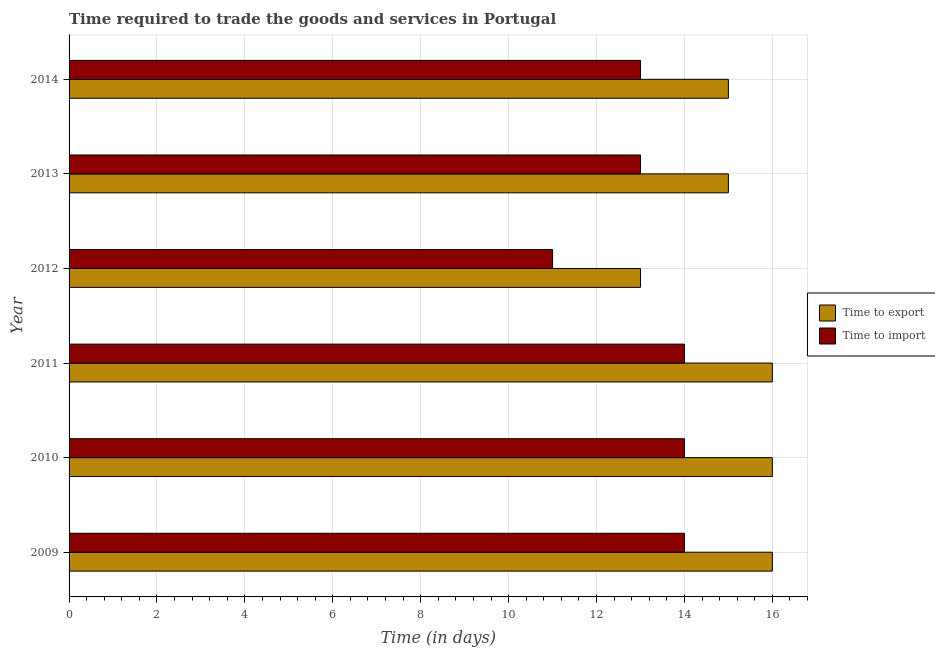How many different coloured bars are there?
Your answer should be compact. 2. Are the number of bars per tick equal to the number of legend labels?
Your answer should be very brief. Yes. Are the number of bars on each tick of the Y-axis equal?
Your response must be concise. Yes. What is the label of the 3rd group of bars from the top?
Your answer should be compact. 2012. What is the time to export in 2014?
Your response must be concise. 15. Across all years, what is the maximum time to export?
Your answer should be very brief. 16. Across all years, what is the minimum time to export?
Your response must be concise. 13. What is the total time to export in the graph?
Your answer should be very brief. 91. What is the difference between the time to export in 2011 and that in 2014?
Ensure brevity in your answer.  1. What is the difference between the time to import in 2010 and the time to export in 2014?
Keep it short and to the point. -1. What is the average time to export per year?
Give a very brief answer. 15.17. In the year 2013, what is the difference between the time to export and time to import?
Ensure brevity in your answer.  2. In how many years, is the time to export greater than 6 days?
Give a very brief answer. 6. What is the ratio of the time to export in 2009 to that in 2011?
Your answer should be very brief. 1. Is the time to export in 2009 less than that in 2010?
Keep it short and to the point. No. What is the difference between the highest and the second highest time to export?
Provide a succinct answer. 0. What is the difference between the highest and the lowest time to export?
Your answer should be very brief. 3. In how many years, is the time to export greater than the average time to export taken over all years?
Your response must be concise. 3. Is the sum of the time to import in 2009 and 2010 greater than the maximum time to export across all years?
Keep it short and to the point. Yes. What does the 2nd bar from the top in 2009 represents?
Offer a terse response. Time to export. What does the 2nd bar from the bottom in 2010 represents?
Your answer should be very brief. Time to import. What is the difference between two consecutive major ticks on the X-axis?
Provide a succinct answer. 2. Does the graph contain any zero values?
Make the answer very short. No. How are the legend labels stacked?
Give a very brief answer. Vertical. What is the title of the graph?
Offer a terse response. Time required to trade the goods and services in Portugal. What is the label or title of the X-axis?
Offer a terse response. Time (in days). What is the Time (in days) of Time to export in 2009?
Keep it short and to the point. 16. What is the Time (in days) in Time to import in 2009?
Keep it short and to the point. 14. What is the Time (in days) in Time to import in 2010?
Ensure brevity in your answer.  14. What is the Time (in days) in Time to export in 2012?
Offer a very short reply. 13. What is the Time (in days) of Time to export in 2013?
Keep it short and to the point. 15. What is the Time (in days) in Time to import in 2013?
Your answer should be very brief. 13. Across all years, what is the maximum Time (in days) of Time to import?
Your response must be concise. 14. Across all years, what is the minimum Time (in days) of Time to import?
Your answer should be very brief. 11. What is the total Time (in days) in Time to export in the graph?
Keep it short and to the point. 91. What is the total Time (in days) in Time to import in the graph?
Your answer should be compact. 79. What is the difference between the Time (in days) in Time to export in 2009 and that in 2010?
Offer a terse response. 0. What is the difference between the Time (in days) in Time to export in 2009 and that in 2013?
Offer a terse response. 1. What is the difference between the Time (in days) of Time to import in 2010 and that in 2012?
Provide a short and direct response. 3. What is the difference between the Time (in days) of Time to import in 2010 and that in 2013?
Offer a very short reply. 1. What is the difference between the Time (in days) in Time to import in 2010 and that in 2014?
Provide a succinct answer. 1. What is the difference between the Time (in days) in Time to export in 2011 and that in 2012?
Your answer should be compact. 3. What is the difference between the Time (in days) in Time to import in 2011 and that in 2013?
Keep it short and to the point. 1. What is the difference between the Time (in days) of Time to export in 2011 and that in 2014?
Offer a terse response. 1. What is the difference between the Time (in days) in Time to export in 2012 and that in 2014?
Make the answer very short. -2. What is the difference between the Time (in days) in Time to import in 2012 and that in 2014?
Provide a short and direct response. -2. What is the difference between the Time (in days) of Time to export in 2013 and that in 2014?
Ensure brevity in your answer.  0. What is the difference between the Time (in days) in Time to import in 2013 and that in 2014?
Provide a short and direct response. 0. What is the difference between the Time (in days) in Time to export in 2009 and the Time (in days) in Time to import in 2012?
Give a very brief answer. 5. What is the difference between the Time (in days) of Time to export in 2010 and the Time (in days) of Time to import in 2013?
Offer a terse response. 3. What is the difference between the Time (in days) of Time to export in 2011 and the Time (in days) of Time to import in 2012?
Your answer should be very brief. 5. What is the difference between the Time (in days) of Time to export in 2011 and the Time (in days) of Time to import in 2013?
Provide a succinct answer. 3. What is the average Time (in days) in Time to export per year?
Your answer should be very brief. 15.17. What is the average Time (in days) of Time to import per year?
Provide a short and direct response. 13.17. In the year 2010, what is the difference between the Time (in days) in Time to export and Time (in days) in Time to import?
Offer a very short reply. 2. In the year 2014, what is the difference between the Time (in days) of Time to export and Time (in days) of Time to import?
Your response must be concise. 2. What is the ratio of the Time (in days) in Time to export in 2009 to that in 2010?
Your response must be concise. 1. What is the ratio of the Time (in days) in Time to export in 2009 to that in 2011?
Your answer should be compact. 1. What is the ratio of the Time (in days) in Time to export in 2009 to that in 2012?
Your answer should be compact. 1.23. What is the ratio of the Time (in days) of Time to import in 2009 to that in 2012?
Your answer should be very brief. 1.27. What is the ratio of the Time (in days) of Time to export in 2009 to that in 2013?
Provide a short and direct response. 1.07. What is the ratio of the Time (in days) of Time to import in 2009 to that in 2013?
Your answer should be very brief. 1.08. What is the ratio of the Time (in days) of Time to export in 2009 to that in 2014?
Provide a succinct answer. 1.07. What is the ratio of the Time (in days) of Time to import in 2009 to that in 2014?
Offer a terse response. 1.08. What is the ratio of the Time (in days) in Time to export in 2010 to that in 2011?
Your answer should be compact. 1. What is the ratio of the Time (in days) of Time to import in 2010 to that in 2011?
Make the answer very short. 1. What is the ratio of the Time (in days) in Time to export in 2010 to that in 2012?
Your answer should be very brief. 1.23. What is the ratio of the Time (in days) of Time to import in 2010 to that in 2012?
Offer a terse response. 1.27. What is the ratio of the Time (in days) of Time to export in 2010 to that in 2013?
Your answer should be compact. 1.07. What is the ratio of the Time (in days) in Time to import in 2010 to that in 2013?
Offer a terse response. 1.08. What is the ratio of the Time (in days) of Time to export in 2010 to that in 2014?
Offer a very short reply. 1.07. What is the ratio of the Time (in days) in Time to export in 2011 to that in 2012?
Your response must be concise. 1.23. What is the ratio of the Time (in days) of Time to import in 2011 to that in 2012?
Your answer should be compact. 1.27. What is the ratio of the Time (in days) in Time to export in 2011 to that in 2013?
Offer a very short reply. 1.07. What is the ratio of the Time (in days) in Time to export in 2011 to that in 2014?
Ensure brevity in your answer.  1.07. What is the ratio of the Time (in days) of Time to import in 2011 to that in 2014?
Your answer should be compact. 1.08. What is the ratio of the Time (in days) of Time to export in 2012 to that in 2013?
Provide a succinct answer. 0.87. What is the ratio of the Time (in days) of Time to import in 2012 to that in 2013?
Offer a very short reply. 0.85. What is the ratio of the Time (in days) in Time to export in 2012 to that in 2014?
Your response must be concise. 0.87. What is the ratio of the Time (in days) in Time to import in 2012 to that in 2014?
Provide a short and direct response. 0.85. What is the ratio of the Time (in days) of Time to export in 2013 to that in 2014?
Give a very brief answer. 1. What is the ratio of the Time (in days) in Time to import in 2013 to that in 2014?
Keep it short and to the point. 1. What is the difference between the highest and the second highest Time (in days) in Time to export?
Your answer should be compact. 0. What is the difference between the highest and the second highest Time (in days) in Time to import?
Provide a short and direct response. 0. 